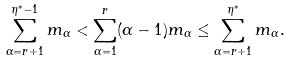<formula> <loc_0><loc_0><loc_500><loc_500>\sum _ { \alpha = r + 1 } ^ { \eta ^ { * } - 1 } m _ { \alpha } < \sum _ { \alpha = 1 } ^ { r } ( \alpha - 1 ) m _ { \alpha } \leq \sum _ { \alpha = r + 1 } ^ { \eta ^ { * } } m _ { \alpha } .</formula> 